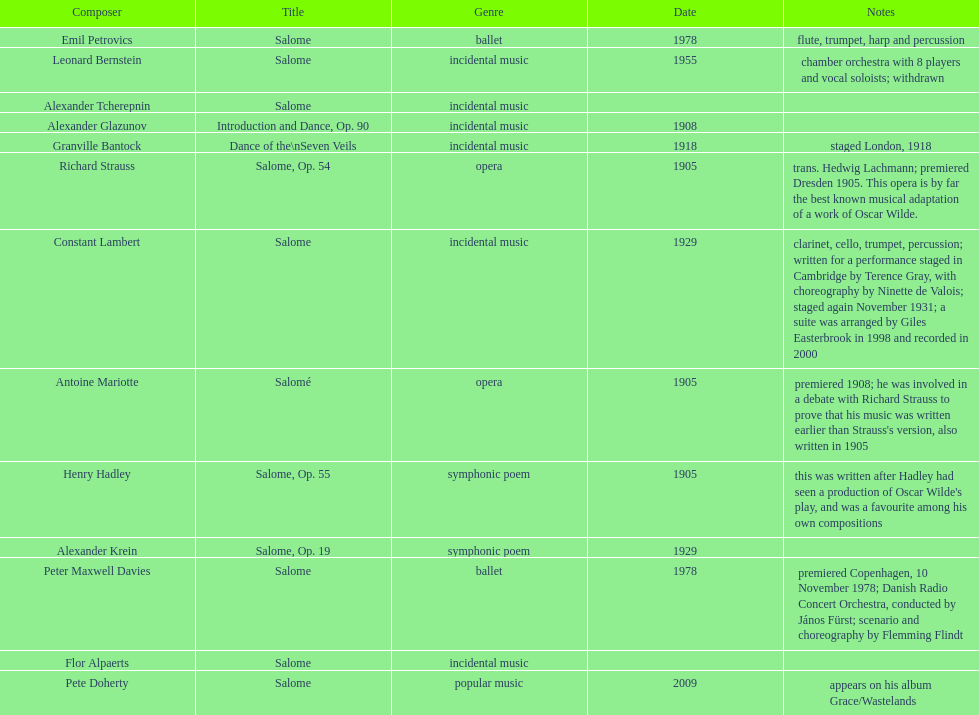Why type of genre was peter maxwell davies' work that was the same as emil petrovics' Ballet. 